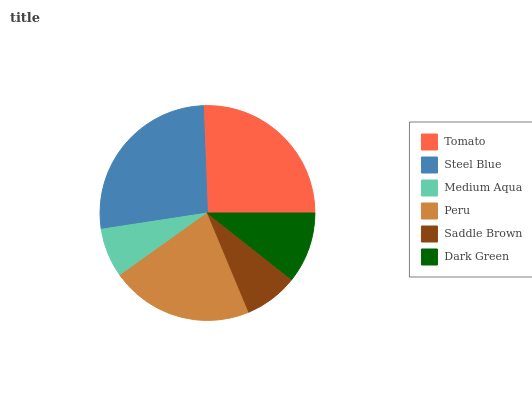Is Medium Aqua the minimum?
Answer yes or no. Yes. Is Steel Blue the maximum?
Answer yes or no. Yes. Is Steel Blue the minimum?
Answer yes or no. No. Is Medium Aqua the maximum?
Answer yes or no. No. Is Steel Blue greater than Medium Aqua?
Answer yes or no. Yes. Is Medium Aqua less than Steel Blue?
Answer yes or no. Yes. Is Medium Aqua greater than Steel Blue?
Answer yes or no. No. Is Steel Blue less than Medium Aqua?
Answer yes or no. No. Is Peru the high median?
Answer yes or no. Yes. Is Dark Green the low median?
Answer yes or no. Yes. Is Steel Blue the high median?
Answer yes or no. No. Is Tomato the low median?
Answer yes or no. No. 